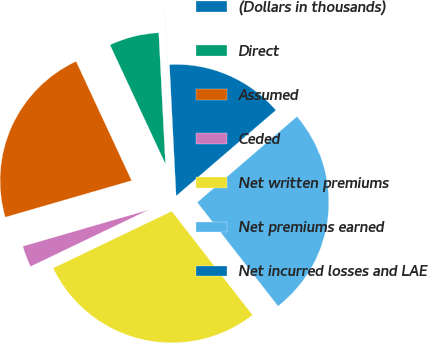Convert chart. <chart><loc_0><loc_0><loc_500><loc_500><pie_chart><fcel>(Dollars in thousands)<fcel>Direct<fcel>Assumed<fcel>Ceded<fcel>Net written premiums<fcel>Net premiums earned<fcel>Net incurred losses and LAE<nl><fcel>0.01%<fcel>6.12%<fcel>22.55%<fcel>2.63%<fcel>28.4%<fcel>25.78%<fcel>14.5%<nl></chart> 